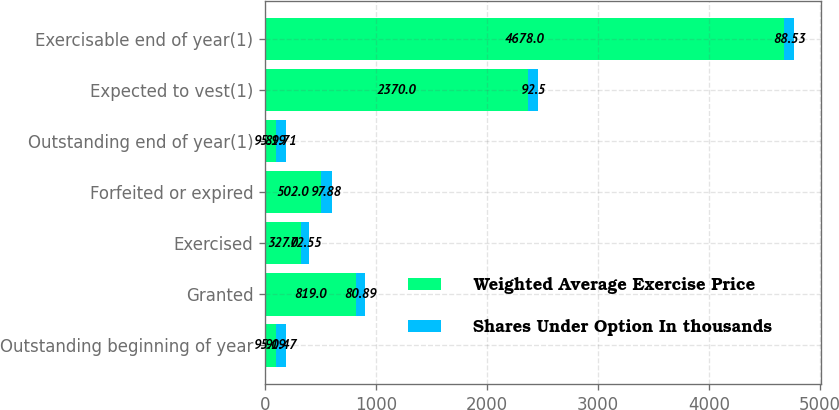Convert chart to OTSL. <chart><loc_0><loc_0><loc_500><loc_500><stacked_bar_chart><ecel><fcel>Outstanding beginning of year<fcel>Granted<fcel>Exercised<fcel>Forfeited or expired<fcel>Outstanding end of year(1)<fcel>Expected to vest(1)<fcel>Exercisable end of year(1)<nl><fcel>Weighted Average Exercise Price<fcel>95.19<fcel>819<fcel>327<fcel>502<fcel>95.19<fcel>2370<fcel>4678<nl><fcel>Shares Under Option In thousands<fcel>90.47<fcel>80.89<fcel>72.55<fcel>97.88<fcel>89.71<fcel>92.5<fcel>88.53<nl></chart> 